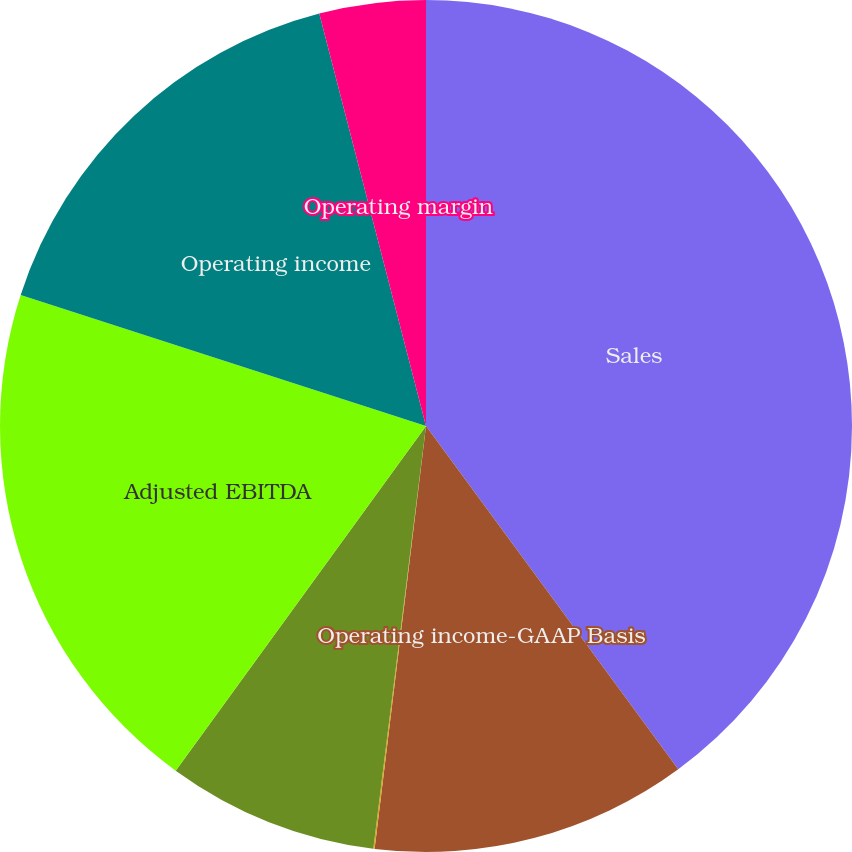Convert chart to OTSL. <chart><loc_0><loc_0><loc_500><loc_500><pie_chart><fcel>Sales<fcel>Operating income-GAAP Basis<fcel>Operating margin-GAAP Basis<fcel>Equity affiliates' income<fcel>Adjusted EBITDA<fcel>Operating income<fcel>Operating margin<nl><fcel>39.91%<fcel>12.01%<fcel>0.05%<fcel>8.02%<fcel>19.98%<fcel>15.99%<fcel>4.03%<nl></chart> 